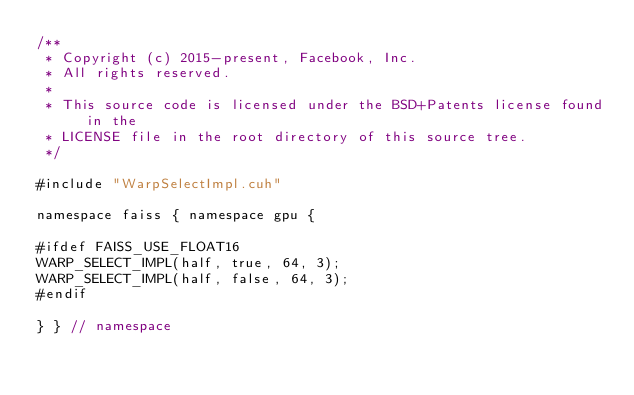Convert code to text. <code><loc_0><loc_0><loc_500><loc_500><_Cuda_>/**
 * Copyright (c) 2015-present, Facebook, Inc.
 * All rights reserved.
 *
 * This source code is licensed under the BSD+Patents license found in the
 * LICENSE file in the root directory of this source tree.
 */

#include "WarpSelectImpl.cuh"

namespace faiss { namespace gpu {

#ifdef FAISS_USE_FLOAT16
WARP_SELECT_IMPL(half, true, 64, 3);
WARP_SELECT_IMPL(half, false, 64, 3);
#endif

} } // namespace
</code> 